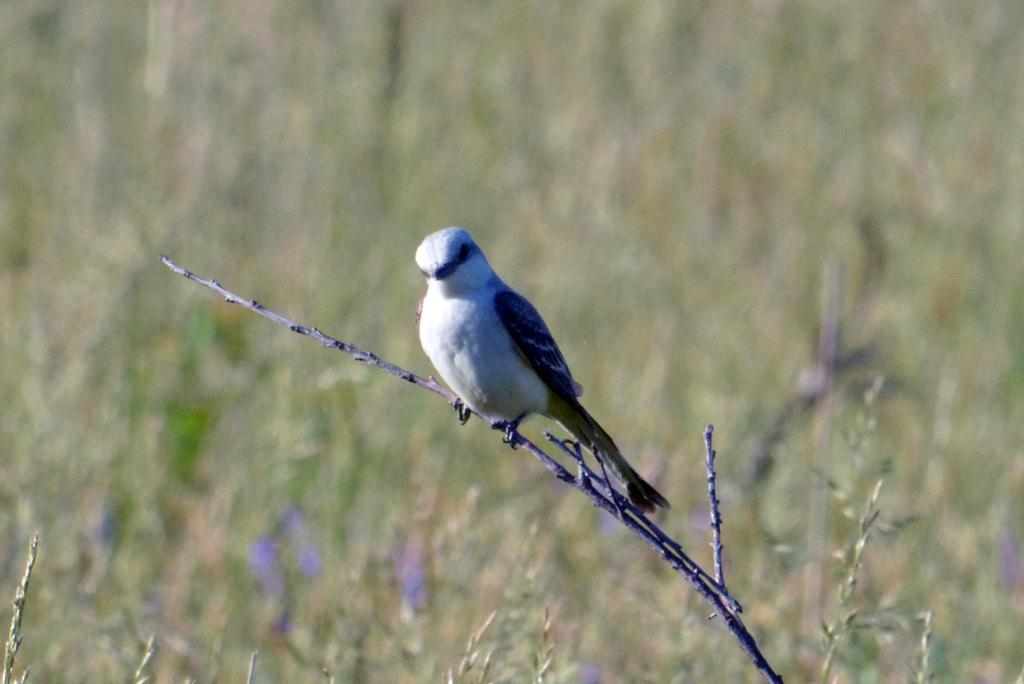What type of animal is present in the image? There is a bird in the image. Where is the bird located in the image? The bird is on the branch of a plant. What else can be seen in the image besides the bird? There are plants visible in the image. What type of canvas is the bird painting on in the image? There is no canvas present in the image, and the bird is not depicted as painting. How many apples can be seen on the branch where the bird is sitting in the image? There are no apples present in the image; only the bird and plants are visible. 